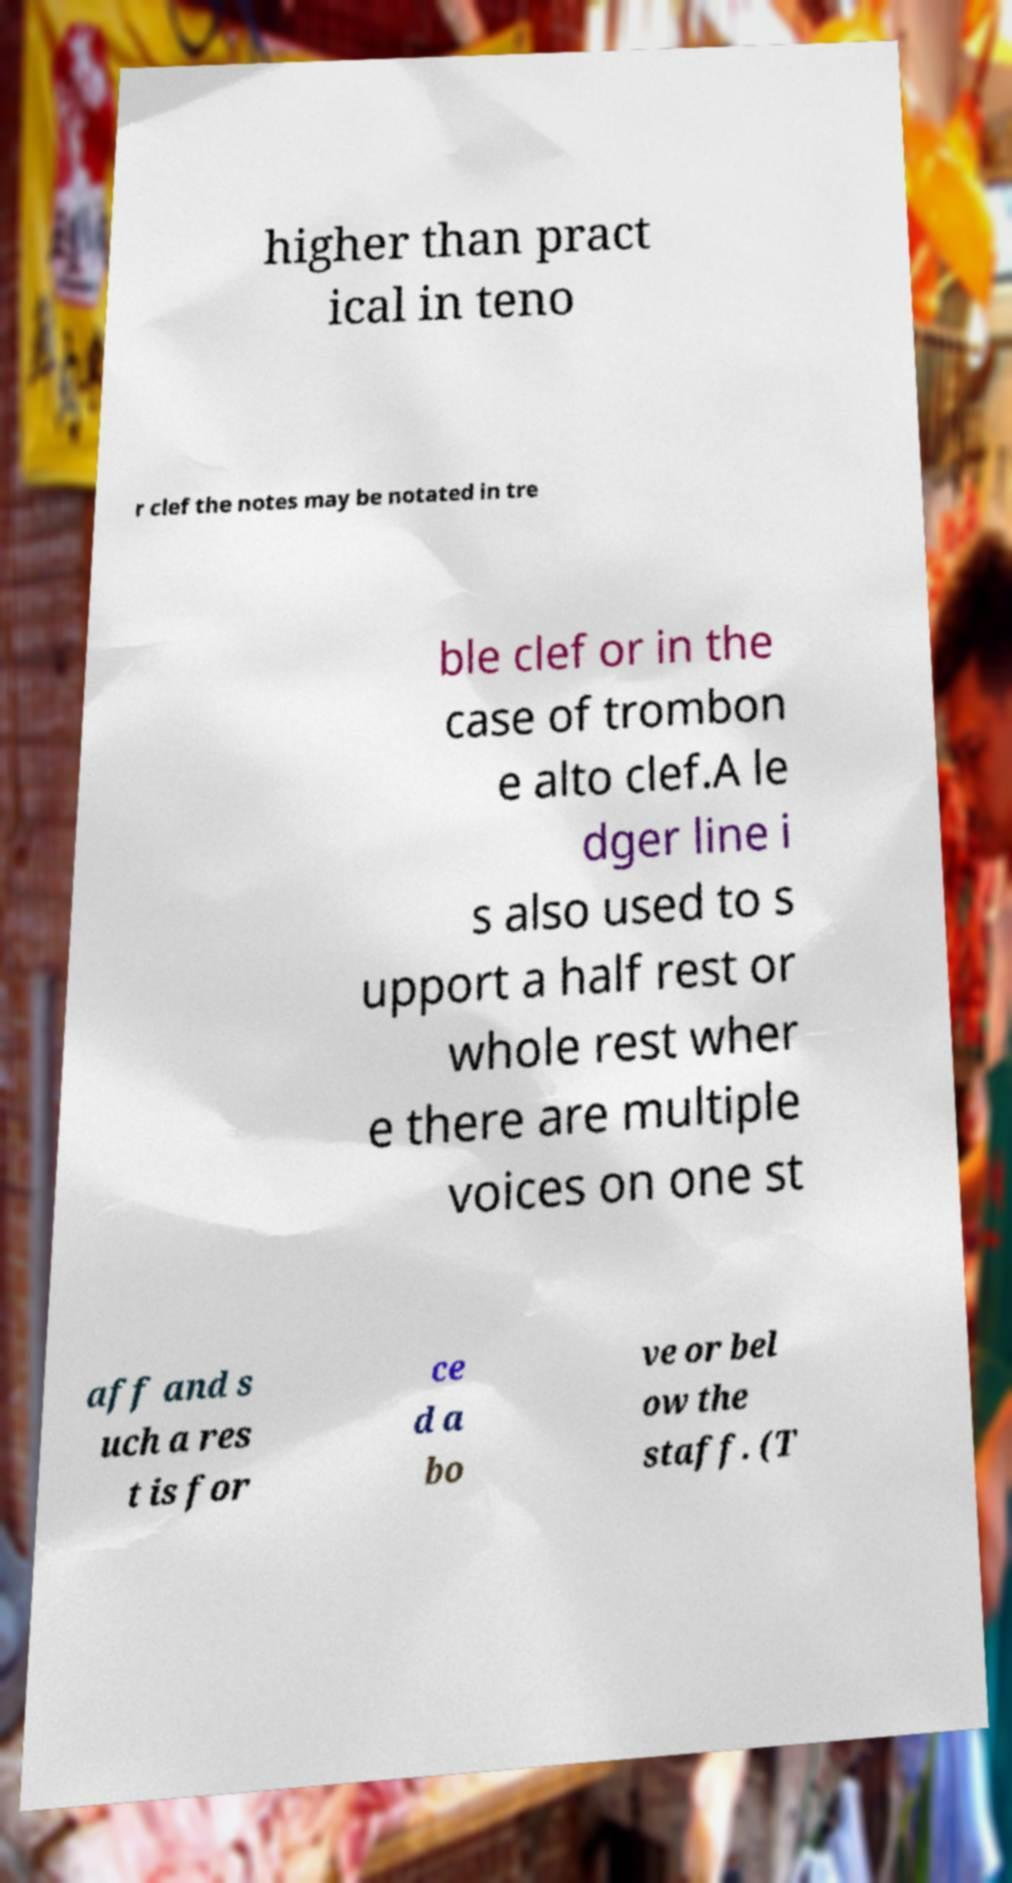Can you read and provide the text displayed in the image?This photo seems to have some interesting text. Can you extract and type it out for me? higher than pract ical in teno r clef the notes may be notated in tre ble clef or in the case of trombon e alto clef.A le dger line i s also used to s upport a half rest or whole rest wher e there are multiple voices on one st aff and s uch a res t is for ce d a bo ve or bel ow the staff. (T 